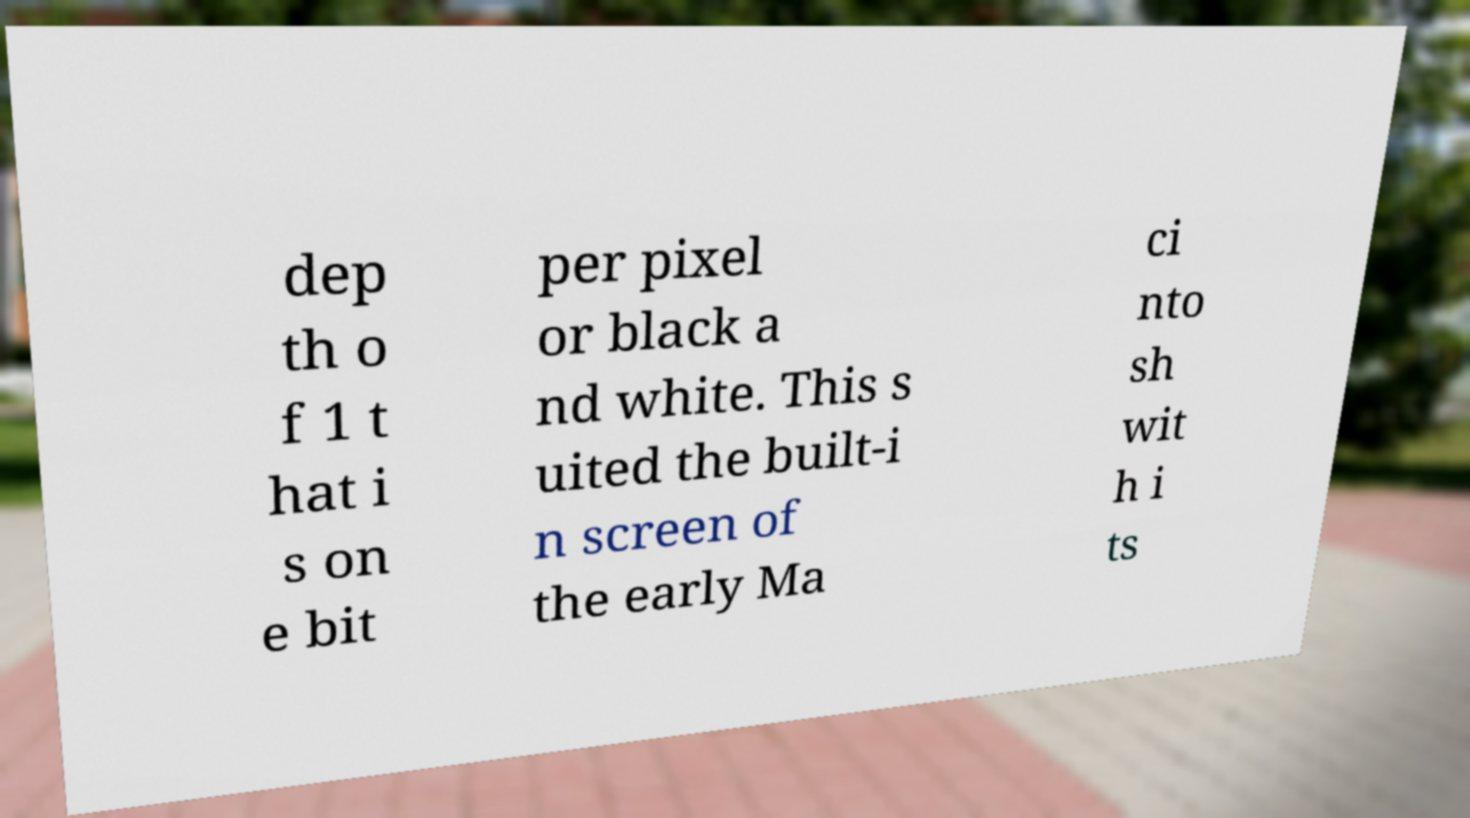Can you read and provide the text displayed in the image?This photo seems to have some interesting text. Can you extract and type it out for me? dep th o f 1 t hat i s on e bit per pixel or black a nd white. This s uited the built-i n screen of the early Ma ci nto sh wit h i ts 